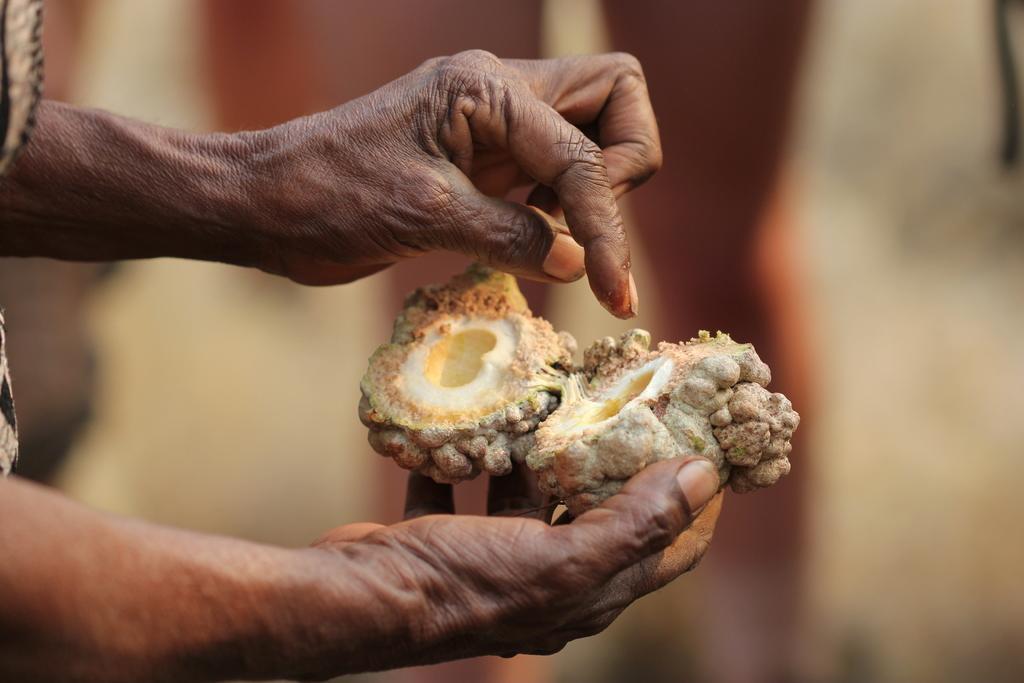How would you summarize this image in a sentence or two? In this picture we can see a person holding a fruit and in the background we can see it is blurry. 